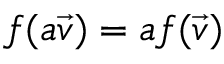<formula> <loc_0><loc_0><loc_500><loc_500>f ( a { \vec { v } } ) = a f ( { \vec { v } } )</formula> 